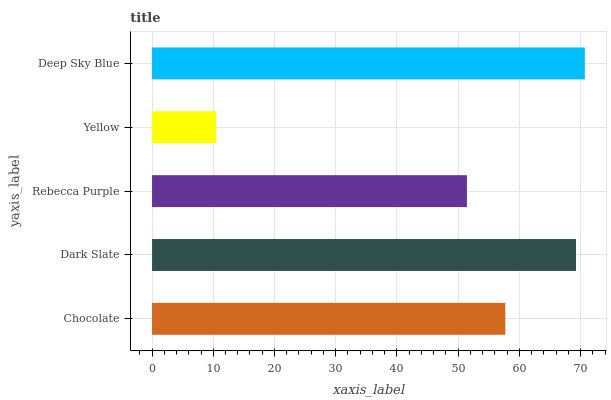Is Yellow the minimum?
Answer yes or no. Yes. Is Deep Sky Blue the maximum?
Answer yes or no. Yes. Is Dark Slate the minimum?
Answer yes or no. No. Is Dark Slate the maximum?
Answer yes or no. No. Is Dark Slate greater than Chocolate?
Answer yes or no. Yes. Is Chocolate less than Dark Slate?
Answer yes or no. Yes. Is Chocolate greater than Dark Slate?
Answer yes or no. No. Is Dark Slate less than Chocolate?
Answer yes or no. No. Is Chocolate the high median?
Answer yes or no. Yes. Is Chocolate the low median?
Answer yes or no. Yes. Is Deep Sky Blue the high median?
Answer yes or no. No. Is Dark Slate the low median?
Answer yes or no. No. 